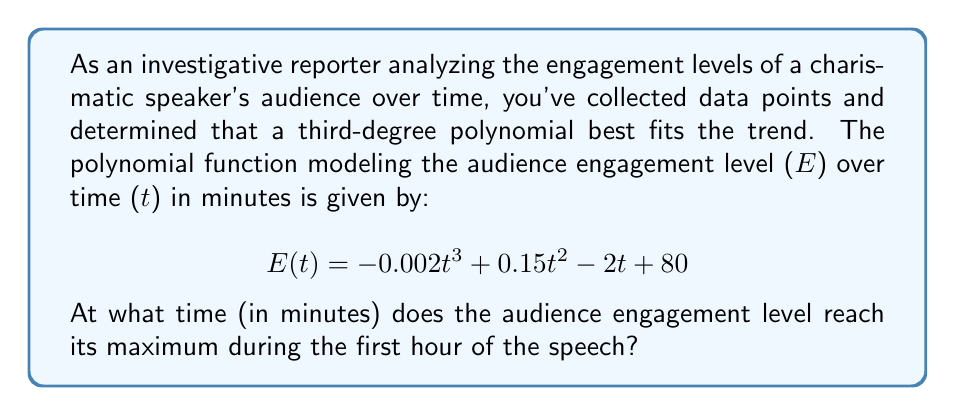Show me your answer to this math problem. To find the maximum engagement level, we need to follow these steps:

1) Find the derivative of the engagement function:
   $$E'(t) = -0.006t^2 + 0.3t - 2$$

2) Set the derivative equal to zero to find critical points:
   $$-0.006t^2 + 0.3t - 2 = 0$$

3) Solve this quadratic equation:
   $$t = \frac{-b \pm \sqrt{b^2 - 4ac}}{2a}$$
   where $a = -0.006$, $b = 0.3$, and $c = -2$

4) Calculating:
   $$t = \frac{-0.3 \pm \sqrt{0.3^2 - 4(-0.006)(-2)}}{2(-0.006)}$$
   $$t = \frac{-0.3 \pm \sqrt{0.09 - 0.048}}{-0.012}$$
   $$t = \frac{-0.3 \pm \sqrt{0.042}}{-0.012}$$
   $$t = \frac{-0.3 \pm 0.2049}{-0.012}$$

5) This gives us two solutions:
   $$t_1 = \frac{-0.3 + 0.2049}{-0.012} \approx 7.925$$
   $$t_2 = \frac{-0.3 - 0.2049}{-0.012} \approx 42.075$$

6) Since we're only interested in the first hour (0 ≤ t ≤ 60), both solutions are valid.

7) To determine which gives the maximum, we can check the second derivative:
   $$E''(t) = -0.012t + 0.3$$

8) Evaluating at t = 7.925:
   $$E''(7.925) = -0.012(7.925) + 0.3 = 0.2049 > 0$$
   This indicates a local minimum.

9) Evaluating at t = 42.075:
   $$E''(42.075) = -0.012(42.075) + 0.3 = -0.2049 < 0$$
   This indicates a local maximum.

Therefore, the engagement level reaches its maximum at approximately 42.075 minutes.
Answer: 42.075 minutes 